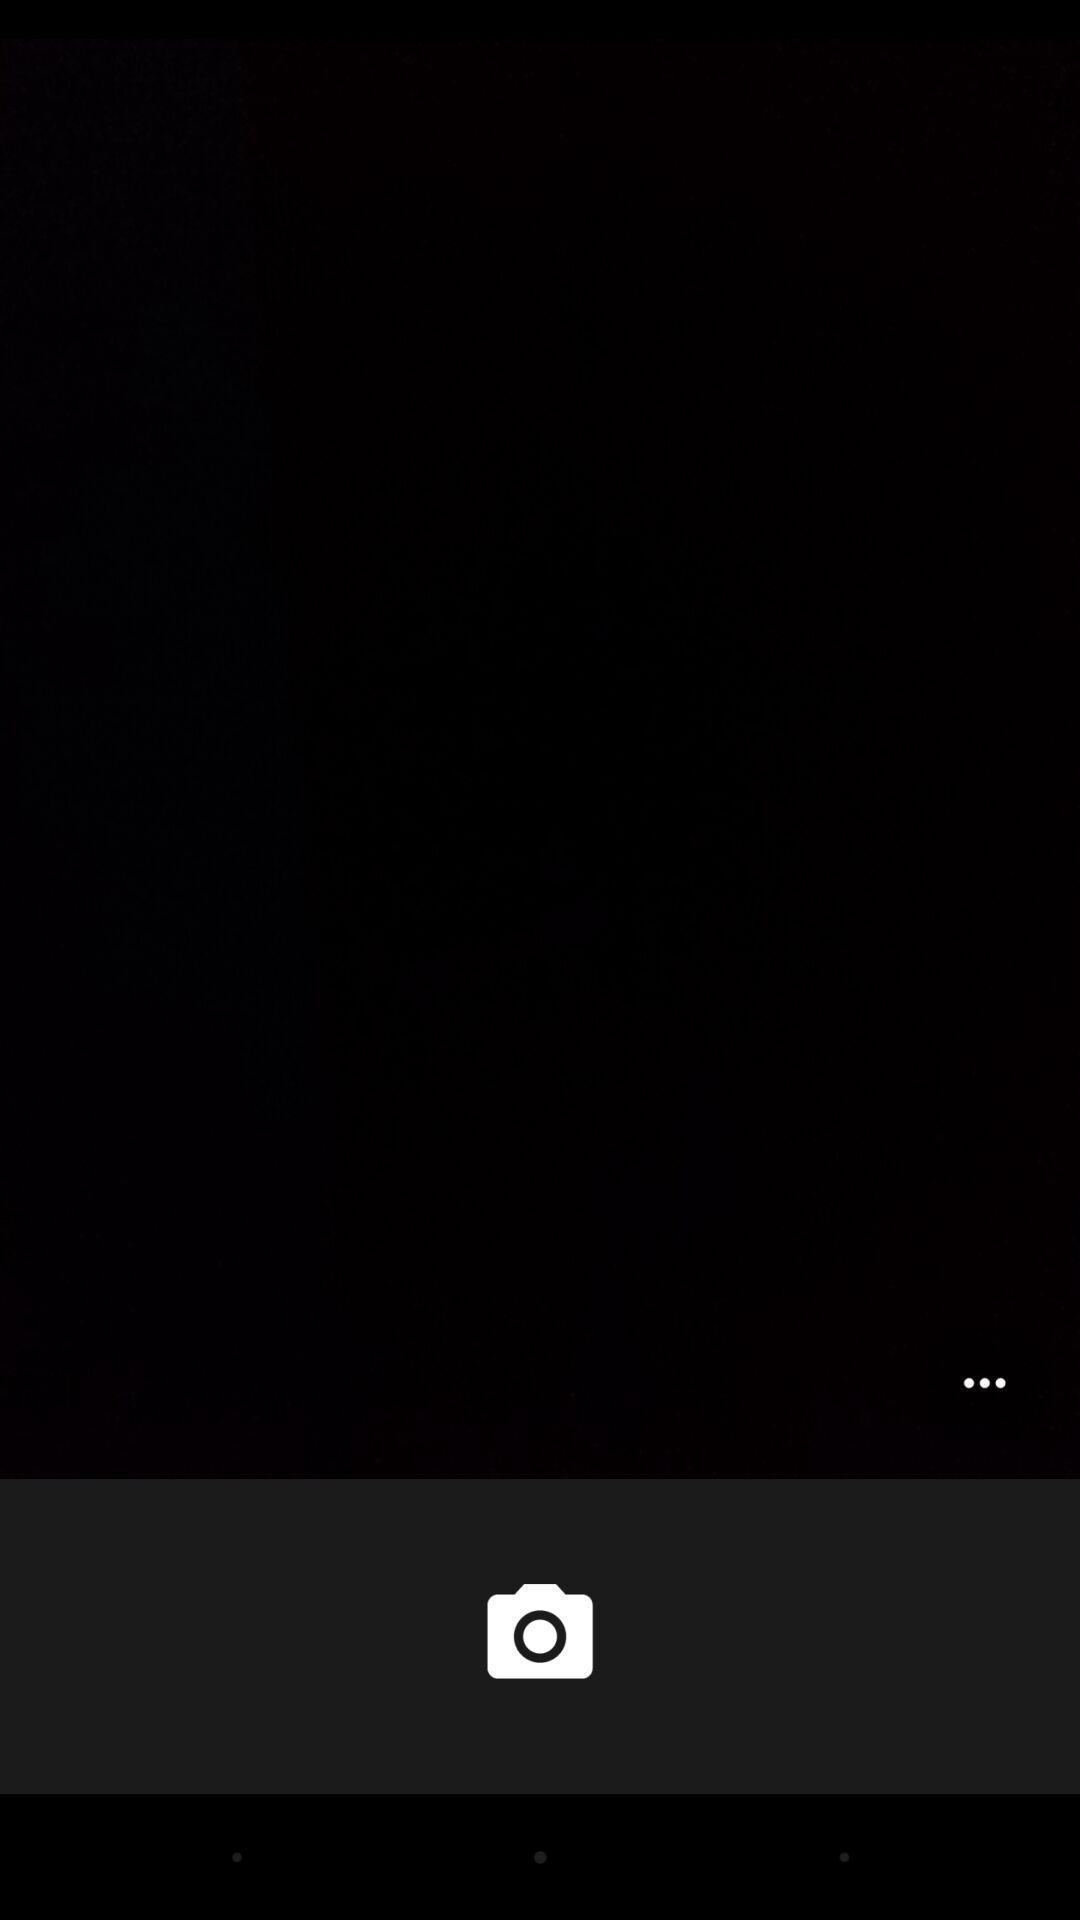Provide a detailed account of this screenshot. Window displaying a camera page. 